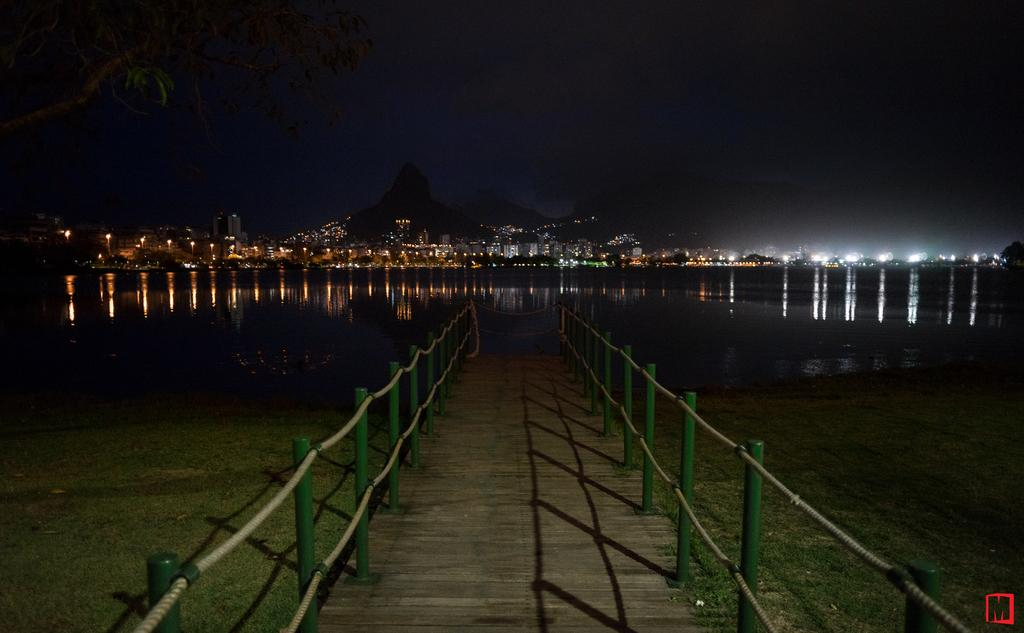What is the primary element visible in the image? There is water in the image. What type of structures can be seen around the water? There are buildings with lighting around in the image. How can people cross the water in the image? There is a foot over bridge in the image. What type of vegetation is present near the water? There is grass on the ground in the image. Are there any trees visible in the image? Yes, there is a tree in the image. How many cattle are grazing near the station in the image? There is no station or cattle present in the image. 